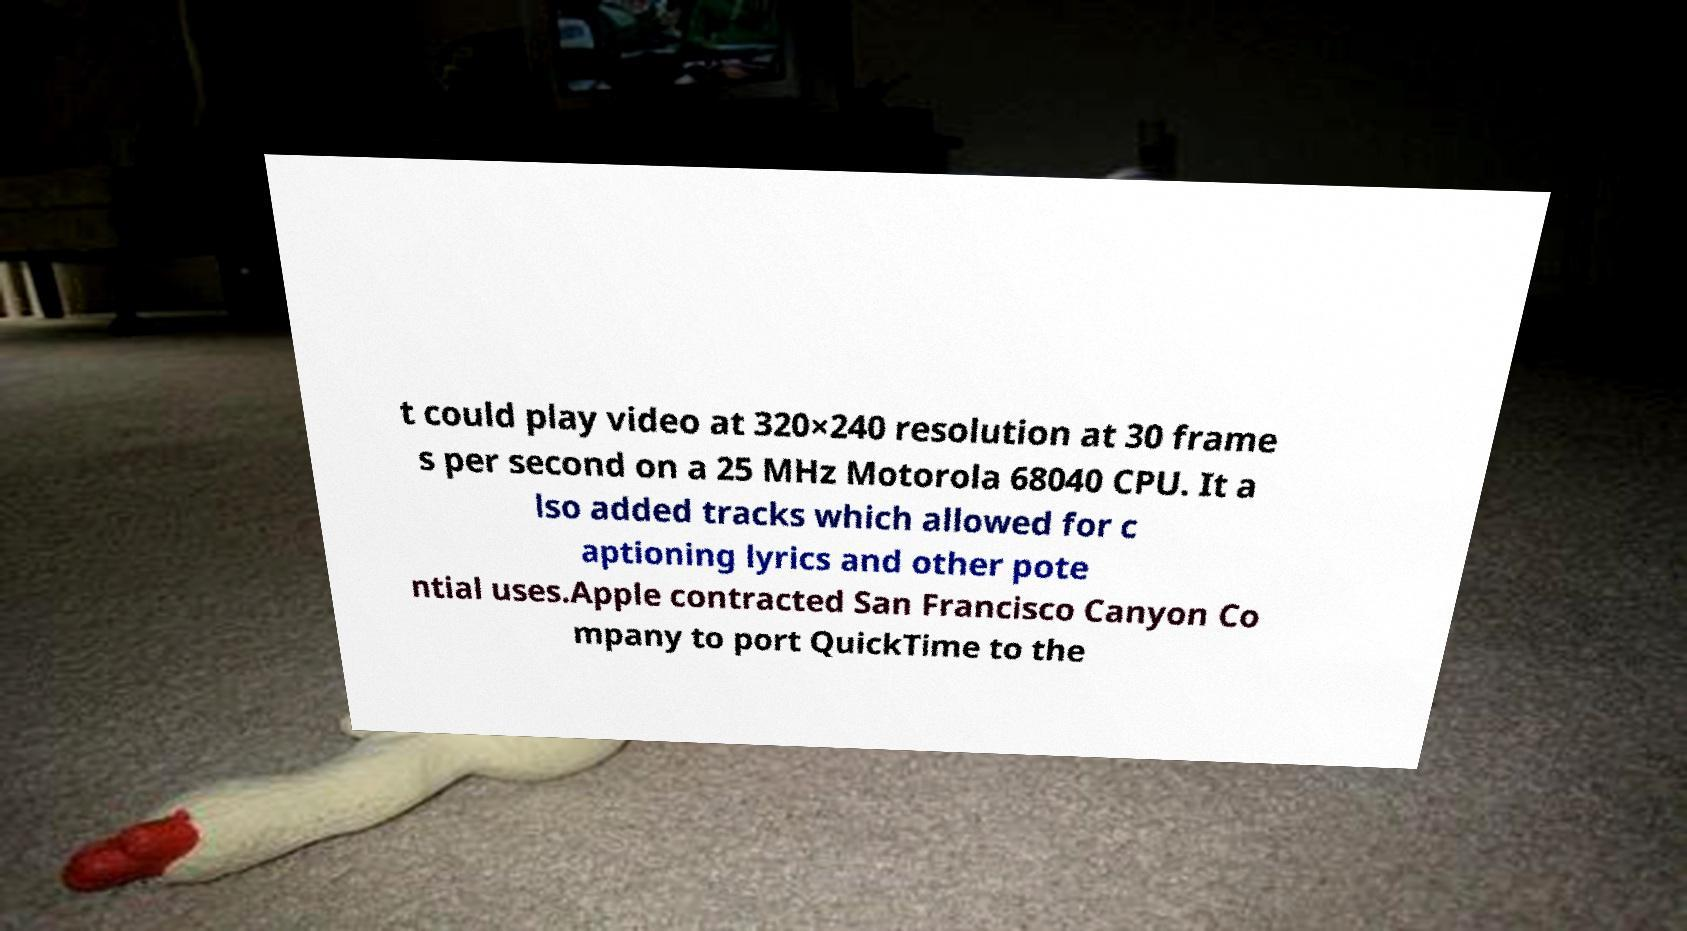What messages or text are displayed in this image? I need them in a readable, typed format. t could play video at 320×240 resolution at 30 frame s per second on a 25 MHz Motorola 68040 CPU. It a lso added tracks which allowed for c aptioning lyrics and other pote ntial uses.Apple contracted San Francisco Canyon Co mpany to port QuickTime to the 